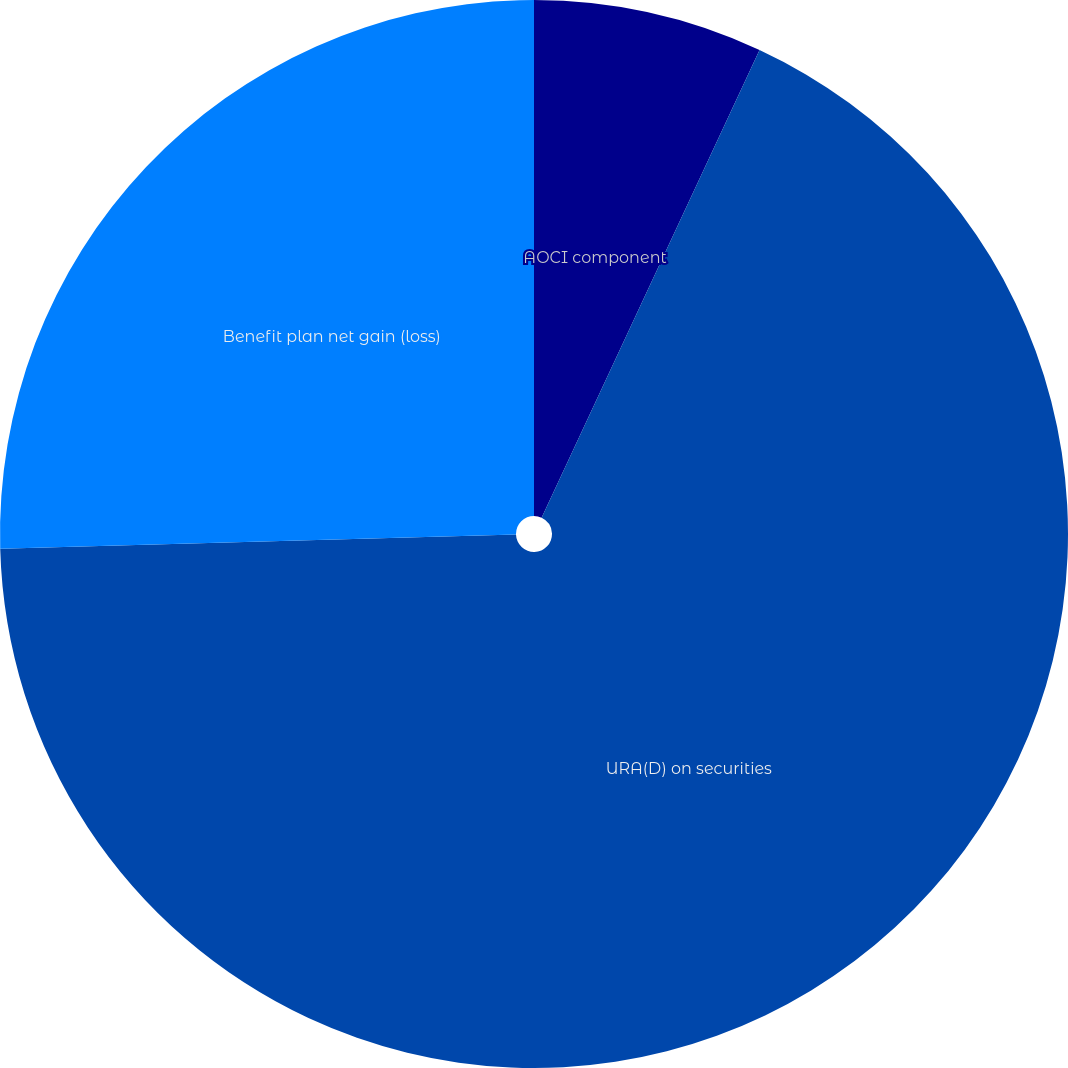Convert chart to OTSL. <chart><loc_0><loc_0><loc_500><loc_500><pie_chart><fcel>AOCI component<fcel>URA(D) on securities<fcel>Benefit plan net gain (loss)<nl><fcel>6.94%<fcel>67.62%<fcel>25.44%<nl></chart> 